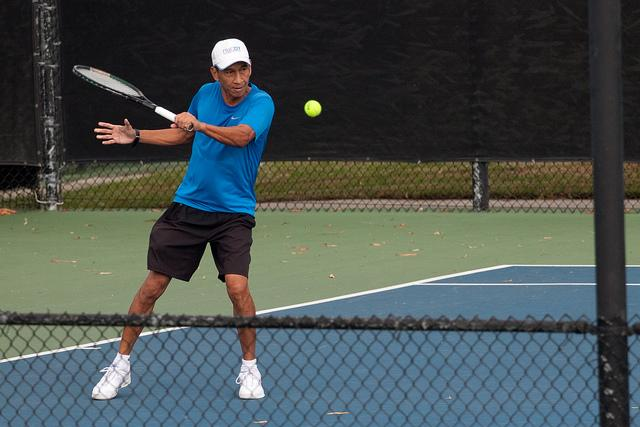What type of shot is this man making?

Choices:
A) double
B) forehand
C) backhand
D) none backhand 